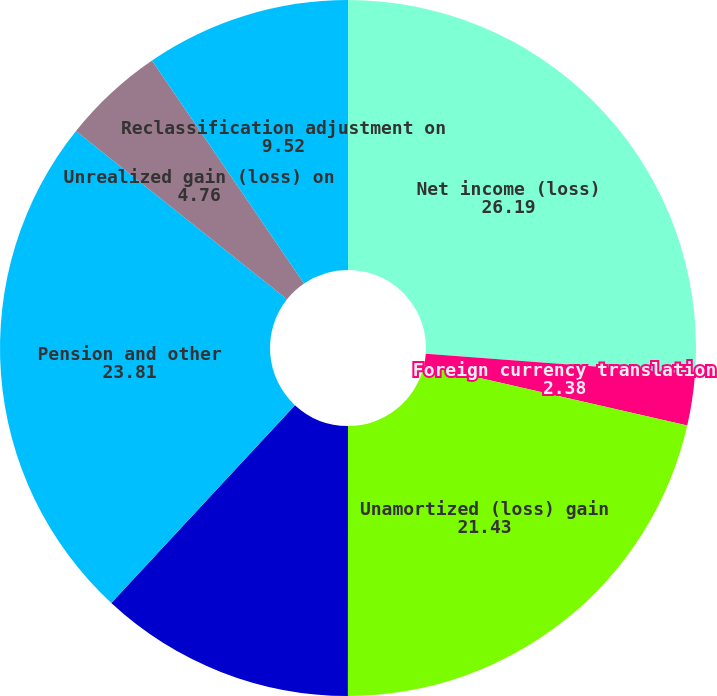<chart> <loc_0><loc_0><loc_500><loc_500><pie_chart><fcel>Net income (loss)<fcel>Foreign currency translation<fcel>Prior service cost recognized<fcel>Unamortized (loss) gain<fcel>Net loss recognized in net<fcel>Pension and other<fcel>Unrealized gain (loss) on<fcel>Reclassification adjustment on<nl><fcel>26.19%<fcel>2.38%<fcel>0.0%<fcel>21.43%<fcel>11.9%<fcel>23.81%<fcel>4.76%<fcel>9.52%<nl></chart> 